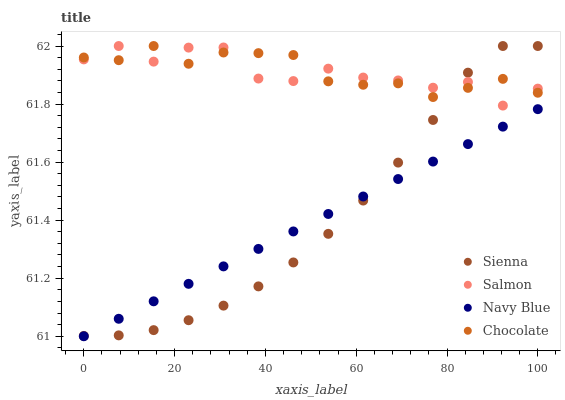Does Navy Blue have the minimum area under the curve?
Answer yes or no. Yes. Does Chocolate have the maximum area under the curve?
Answer yes or no. Yes. Does Salmon have the minimum area under the curve?
Answer yes or no. No. Does Salmon have the maximum area under the curve?
Answer yes or no. No. Is Navy Blue the smoothest?
Answer yes or no. Yes. Is Salmon the roughest?
Answer yes or no. Yes. Is Salmon the smoothest?
Answer yes or no. No. Is Navy Blue the roughest?
Answer yes or no. No. Does Navy Blue have the lowest value?
Answer yes or no. Yes. Does Salmon have the lowest value?
Answer yes or no. No. Does Chocolate have the highest value?
Answer yes or no. Yes. Does Salmon have the highest value?
Answer yes or no. No. Is Navy Blue less than Chocolate?
Answer yes or no. Yes. Is Salmon greater than Navy Blue?
Answer yes or no. Yes. Does Navy Blue intersect Sienna?
Answer yes or no. Yes. Is Navy Blue less than Sienna?
Answer yes or no. No. Is Navy Blue greater than Sienna?
Answer yes or no. No. Does Navy Blue intersect Chocolate?
Answer yes or no. No. 